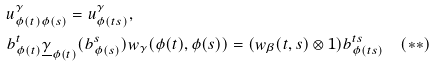Convert formula to latex. <formula><loc_0><loc_0><loc_500><loc_500>& u _ { \phi ( t ) \phi ( s ) } ^ { \gamma } = u _ { \phi ( t s ) } ^ { \gamma } , \\ & b _ { \phi ( t ) } ^ { t } \underline { \gamma } _ { \phi ( t ) } ( b _ { \phi ( s ) } ^ { s } ) w _ { \gamma } ( \phi ( t ) , \phi ( s ) ) = ( w _ { \beta } ( t , s ) \otimes 1 ) b _ { \phi ( t s ) } ^ { t s } \quad ( * * )</formula> 